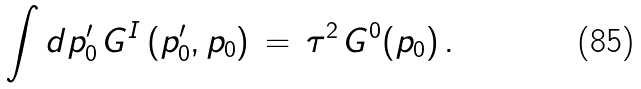<formula> <loc_0><loc_0><loc_500><loc_500>\quad \int d p ^ { \prime } _ { 0 } \, G ^ { I } \, ( p ^ { \prime } _ { 0 } , p _ { 0 } ) \, = \, \tau ^ { 2 } \, G ^ { 0 } ( p _ { 0 } ) \, .</formula> 